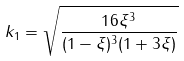<formula> <loc_0><loc_0><loc_500><loc_500>k _ { 1 } = \sqrt { \frac { 1 6 \xi ^ { 3 } } { ( 1 - \xi ) ^ { 3 } ( 1 + 3 \xi ) } }</formula> 